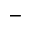Convert formula to latex. <formula><loc_0><loc_0><loc_500><loc_500>-</formula> 